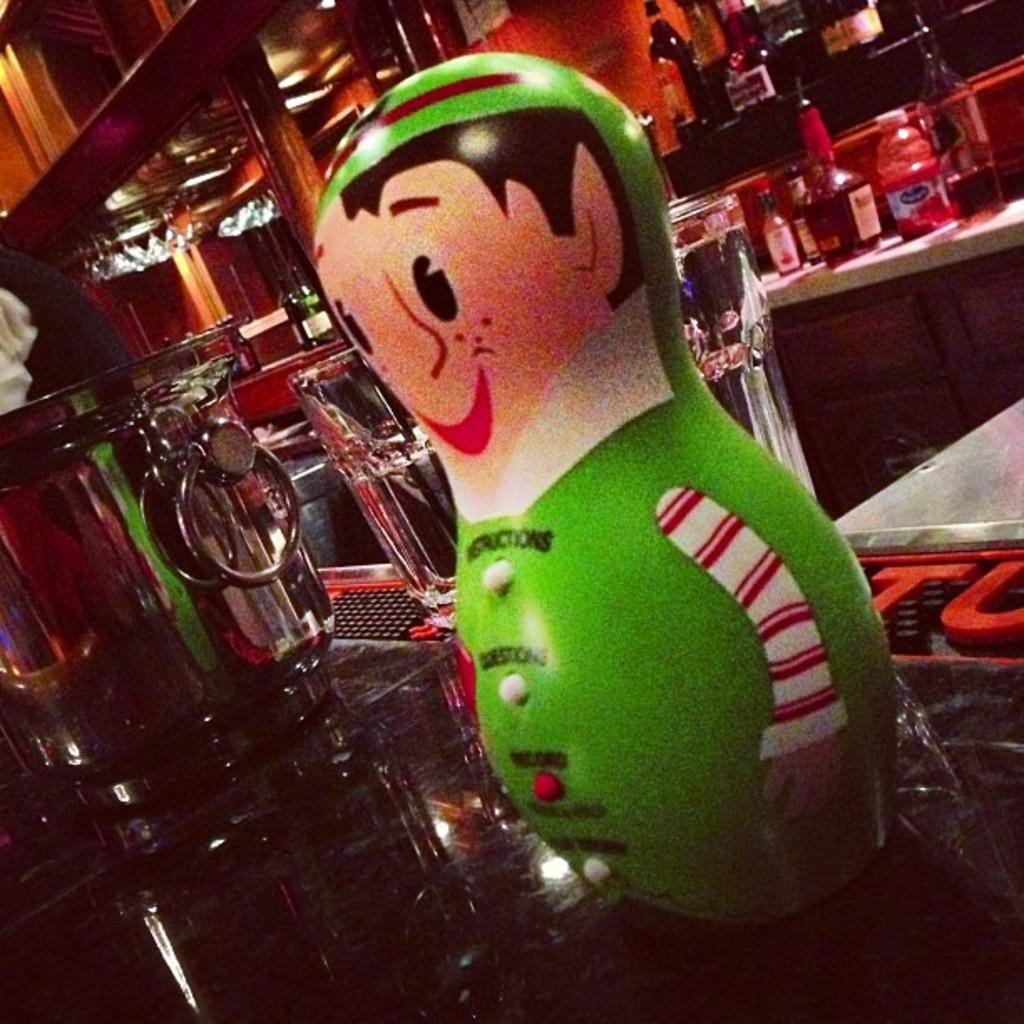What is placed on the table in the image? There is a toy placed on a table in the image. What can be seen in the background of the image? In the background of the image, there are bottles, a handle, lights, and pillars. Who won the competition between the mom and the arm in the image? There is no competition between a mom and an arm present in the image. 